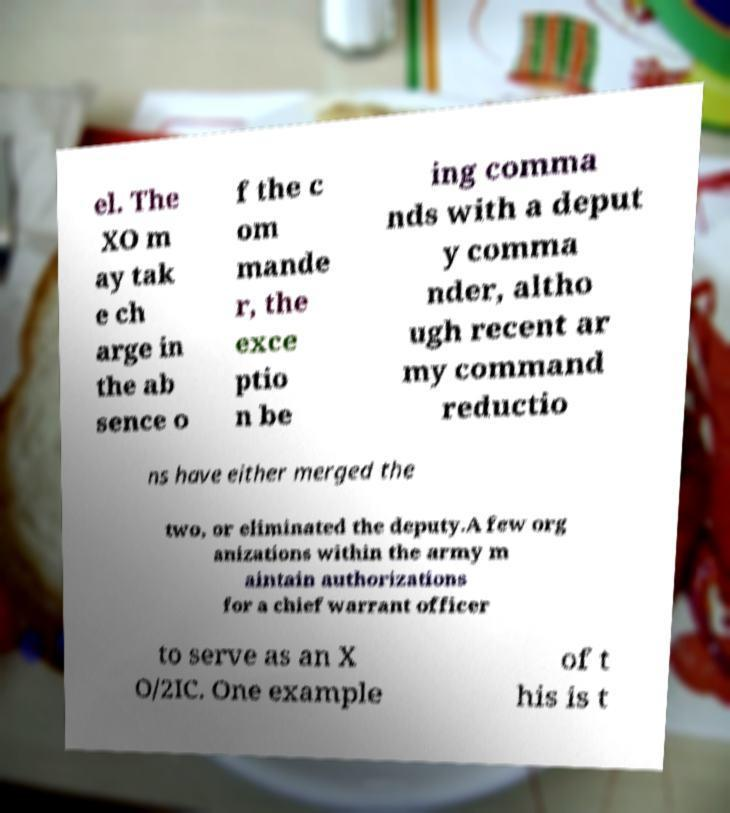There's text embedded in this image that I need extracted. Can you transcribe it verbatim? el. The XO m ay tak e ch arge in the ab sence o f the c om mande r, the exce ptio n be ing comma nds with a deput y comma nder, altho ugh recent ar my command reductio ns have either merged the two, or eliminated the deputy.A few org anizations within the army m aintain authorizations for a chief warrant officer to serve as an X O/2IC. One example of t his is t 